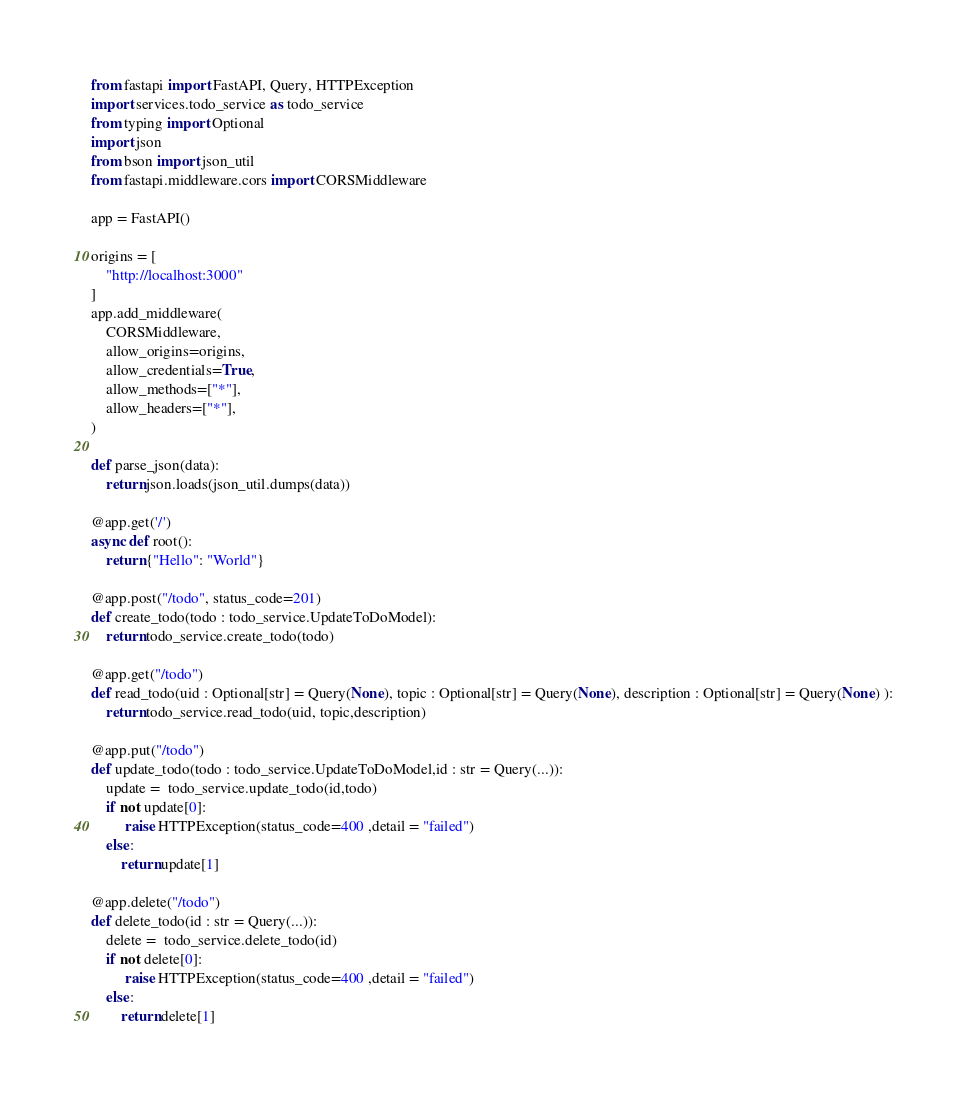Convert code to text. <code><loc_0><loc_0><loc_500><loc_500><_Python_>from fastapi import FastAPI, Query, HTTPException
import services.todo_service as todo_service
from typing import Optional
import json
from bson import json_util
from fastapi.middleware.cors import CORSMiddleware

app = FastAPI()

origins = [
    "http://localhost:3000"
]
app.add_middleware(
	CORSMiddleware,
	allow_origins=origins,
	allow_credentials=True,
	allow_methods=["*"],
	allow_headers=["*"],
)

def parse_json(data):
    return json.loads(json_util.dumps(data))

@app.get('/')
async def root():
	return {"Hello": "World"}

@app.post("/todo", status_code=201)
def create_todo(todo : todo_service.UpdateToDoModel):
    return todo_service.create_todo(todo)

@app.get("/todo")
def read_todo(uid : Optional[str] = Query(None), topic : Optional[str] = Query(None), description : Optional[str] = Query(None) ):
    return todo_service.read_todo(uid, topic,description)

@app.put("/todo")
def update_todo(todo : todo_service.UpdateToDoModel,id : str = Query(...)):
    update =  todo_service.update_todo(id,todo)
    if not update[0]:
         raise HTTPException(status_code=400 ,detail = "failed")
    else:
        return update[1]

@app.delete("/todo")
def delete_todo(id : str = Query(...)):
    delete =  todo_service.delete_todo(id)
    if not delete[0]:
         raise HTTPException(status_code=400 ,detail = "failed")
    else:
        return delete[1]
</code> 